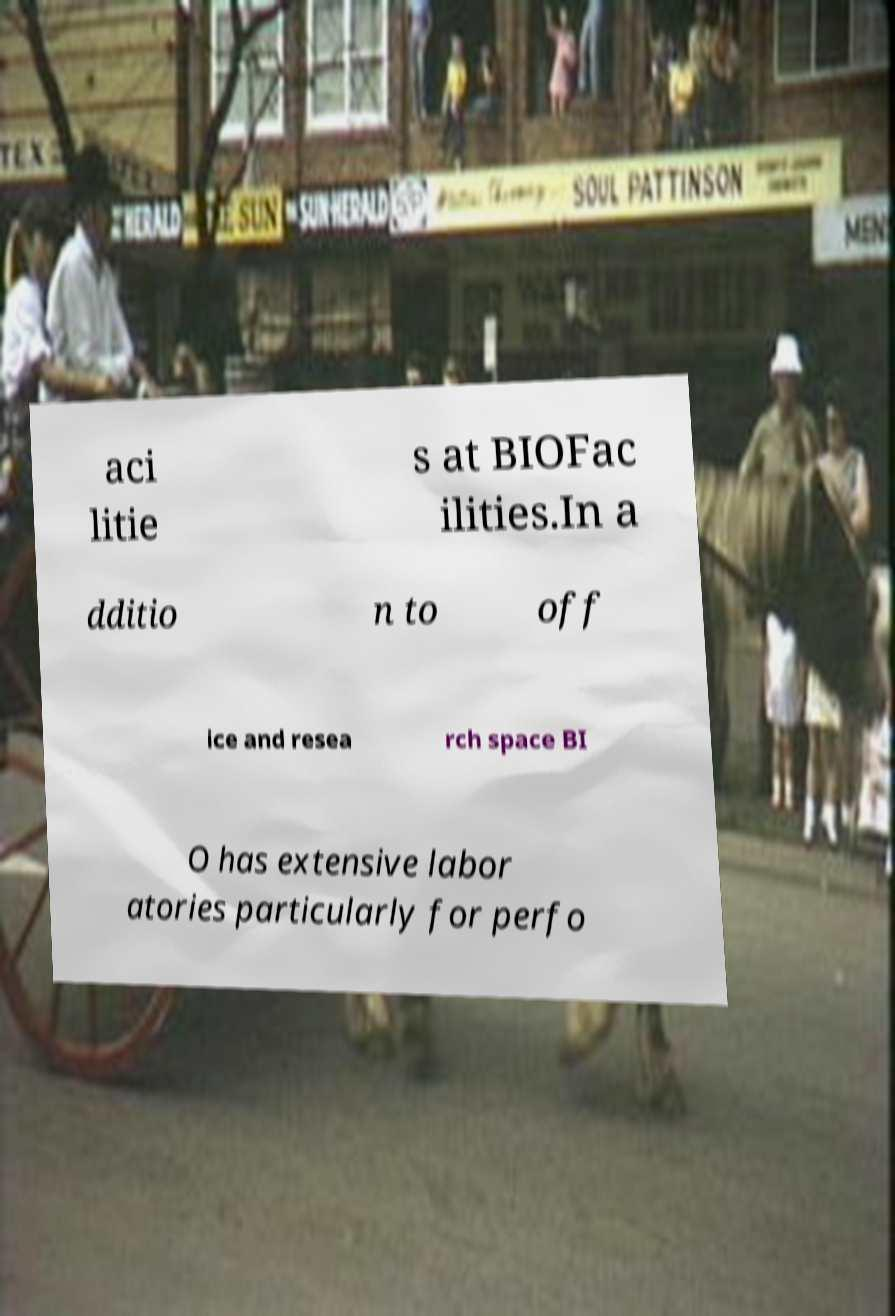There's text embedded in this image that I need extracted. Can you transcribe it verbatim? aci litie s at BIOFac ilities.In a dditio n to off ice and resea rch space BI O has extensive labor atories particularly for perfo 